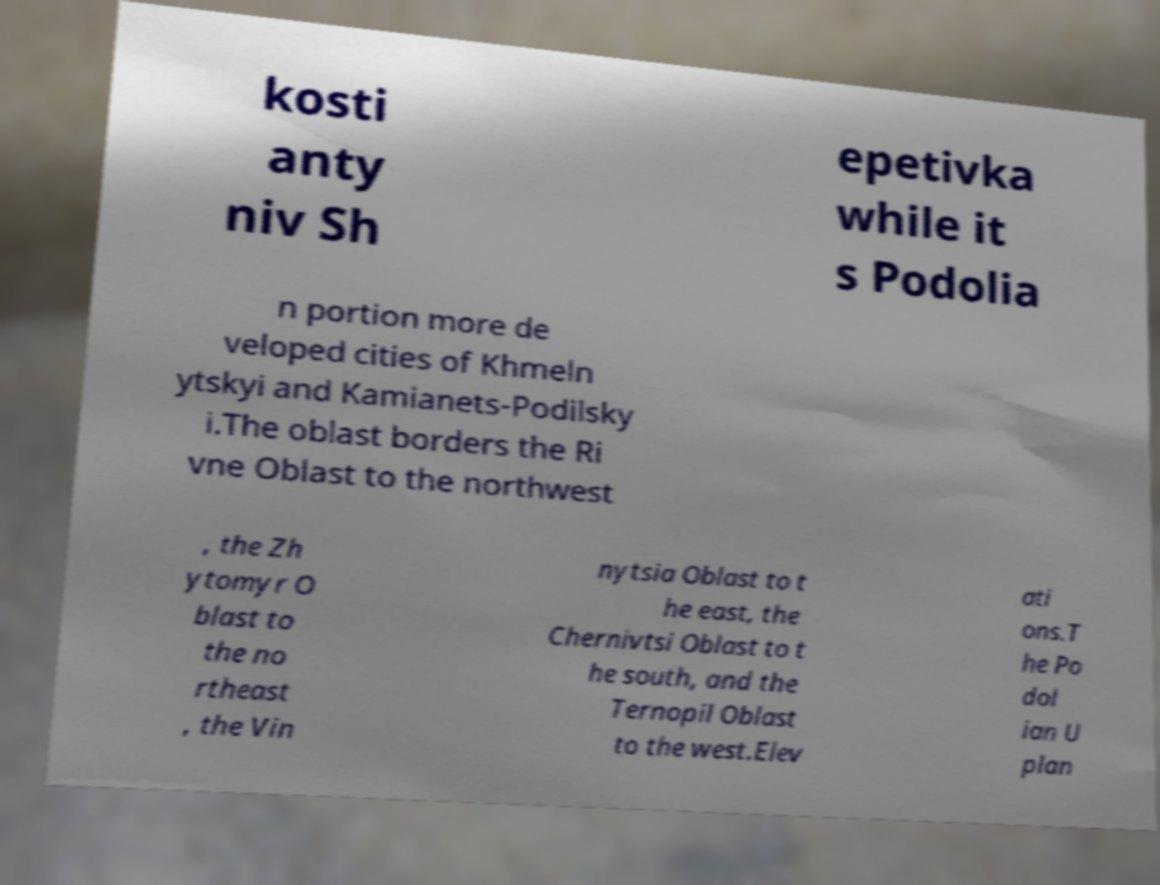What messages or text are displayed in this image? I need them in a readable, typed format. kosti anty niv Sh epetivka while it s Podolia n portion more de veloped cities of Khmeln ytskyi and Kamianets-Podilsky i.The oblast borders the Ri vne Oblast to the northwest , the Zh ytomyr O blast to the no rtheast , the Vin nytsia Oblast to t he east, the Chernivtsi Oblast to t he south, and the Ternopil Oblast to the west.Elev ati ons.T he Po dol ian U plan 